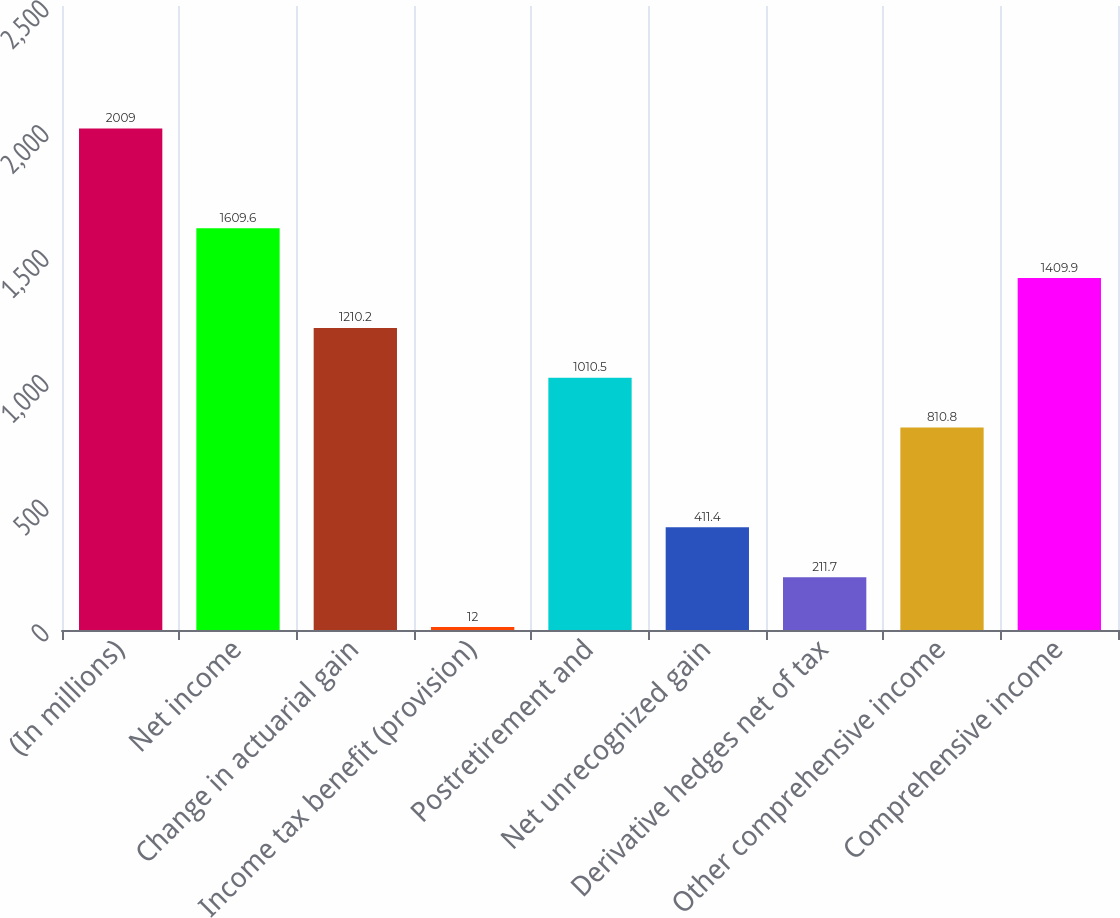<chart> <loc_0><loc_0><loc_500><loc_500><bar_chart><fcel>(In millions)<fcel>Net income<fcel>Change in actuarial gain<fcel>Income tax benefit (provision)<fcel>Postretirement and<fcel>Net unrecognized gain<fcel>Derivative hedges net of tax<fcel>Other comprehensive income<fcel>Comprehensive income<nl><fcel>2009<fcel>1609.6<fcel>1210.2<fcel>12<fcel>1010.5<fcel>411.4<fcel>211.7<fcel>810.8<fcel>1409.9<nl></chart> 